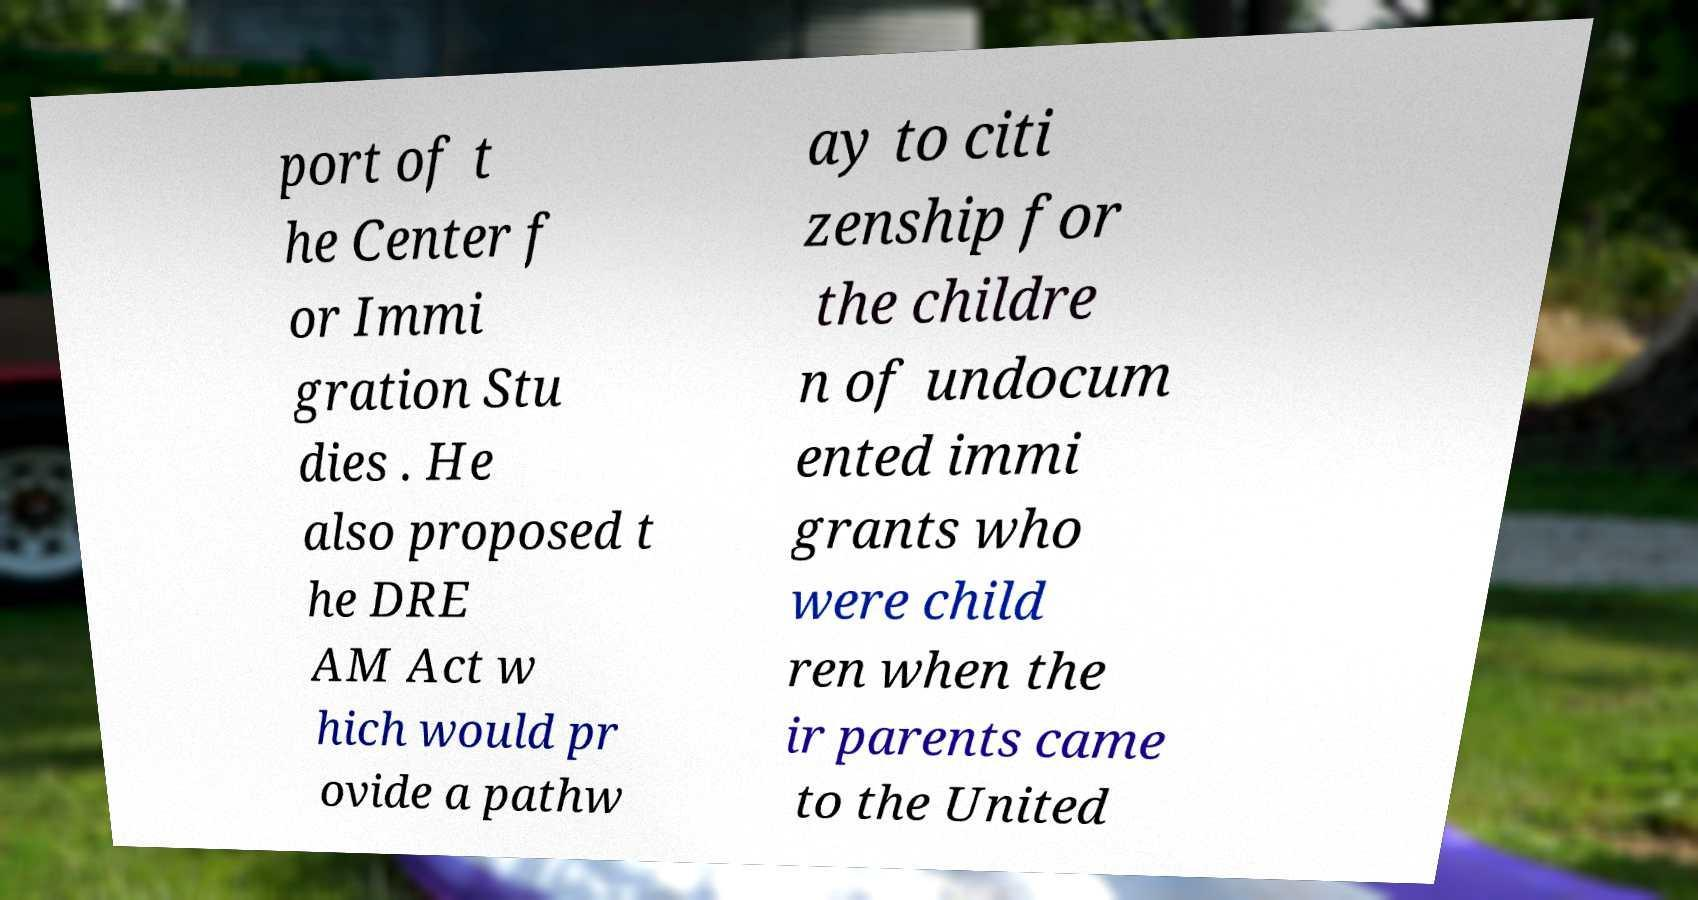Can you read and provide the text displayed in the image?This photo seems to have some interesting text. Can you extract and type it out for me? port of t he Center f or Immi gration Stu dies . He also proposed t he DRE AM Act w hich would pr ovide a pathw ay to citi zenship for the childre n of undocum ented immi grants who were child ren when the ir parents came to the United 